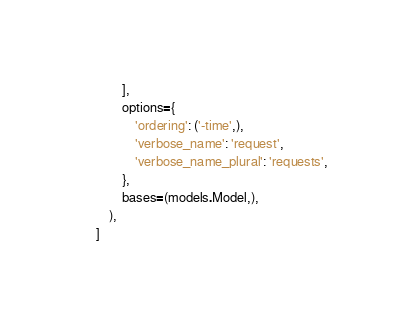Convert code to text. <code><loc_0><loc_0><loc_500><loc_500><_Python_>            ],
            options={
                'ordering': ('-time',),
                'verbose_name': 'request',
                'verbose_name_plural': 'requests',
            },
            bases=(models.Model,),
        ),
    ]
</code> 